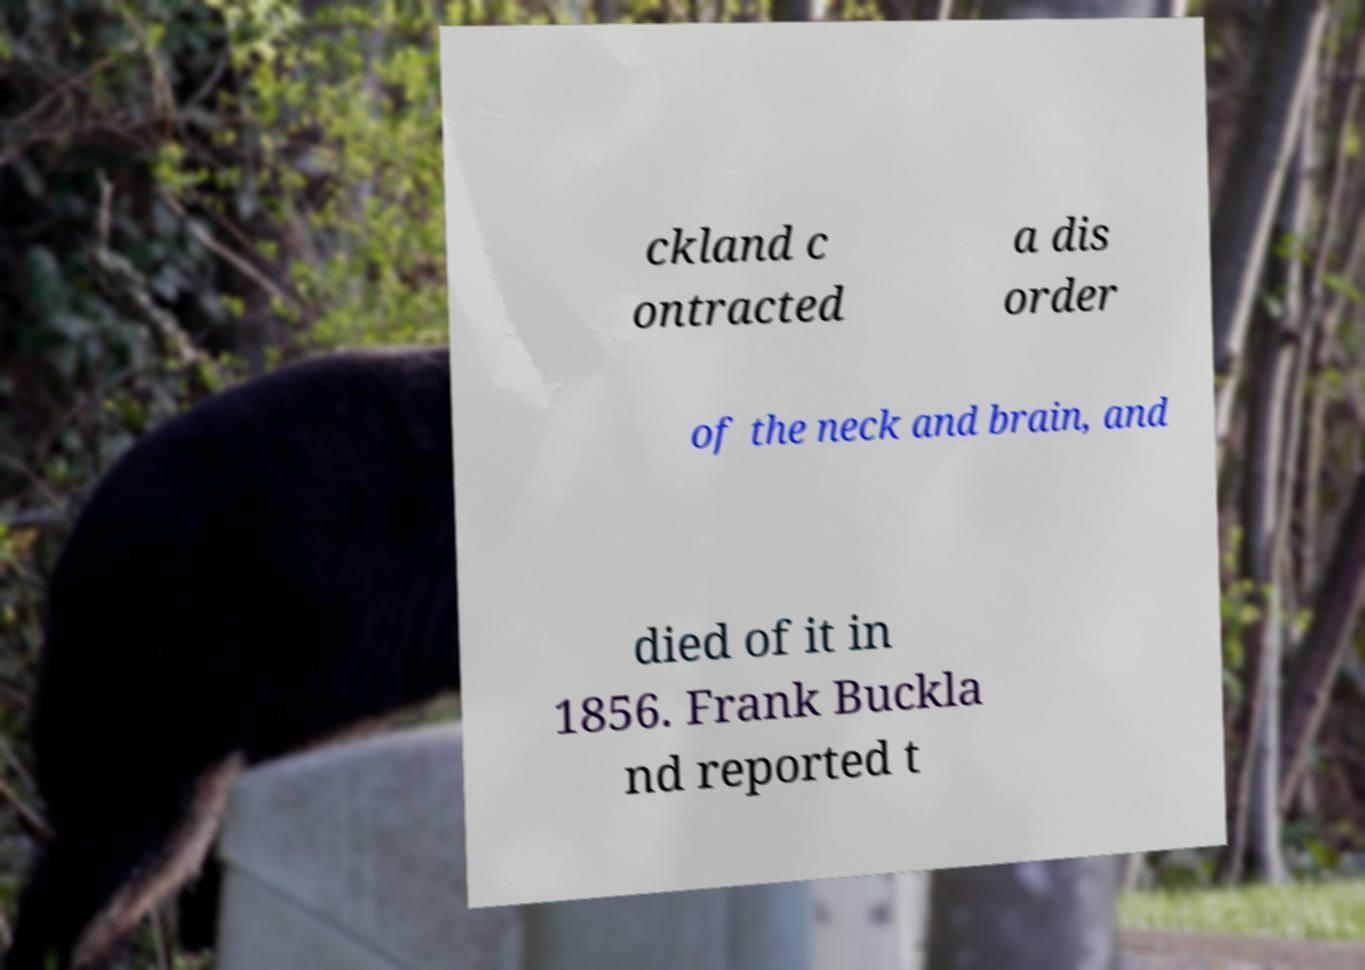Please read and relay the text visible in this image. What does it say? ckland c ontracted a dis order of the neck and brain, and died of it in 1856. Frank Buckla nd reported t 